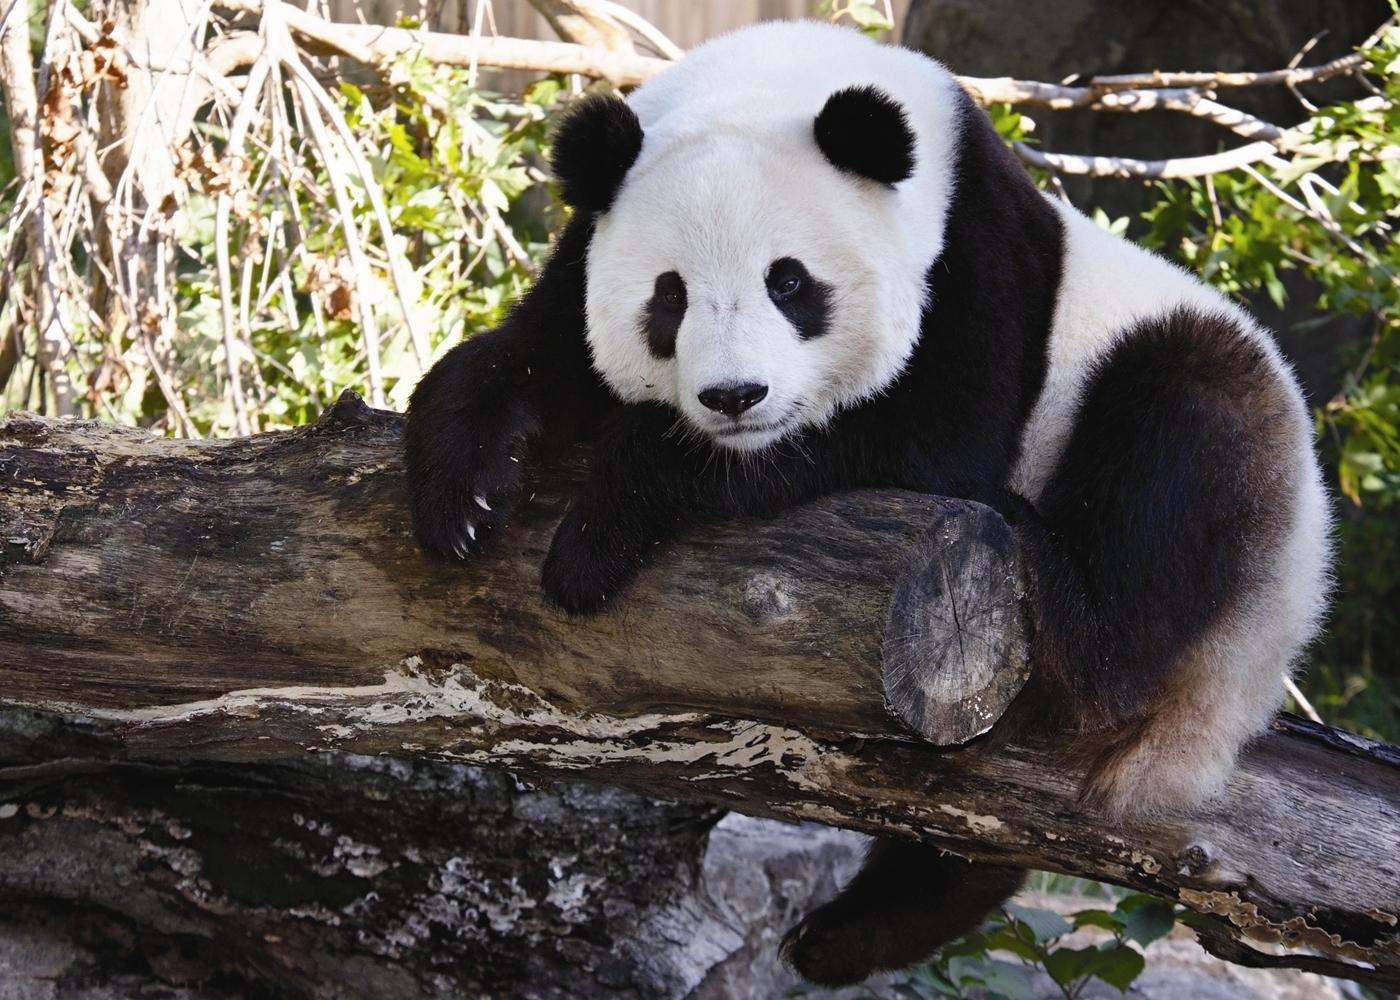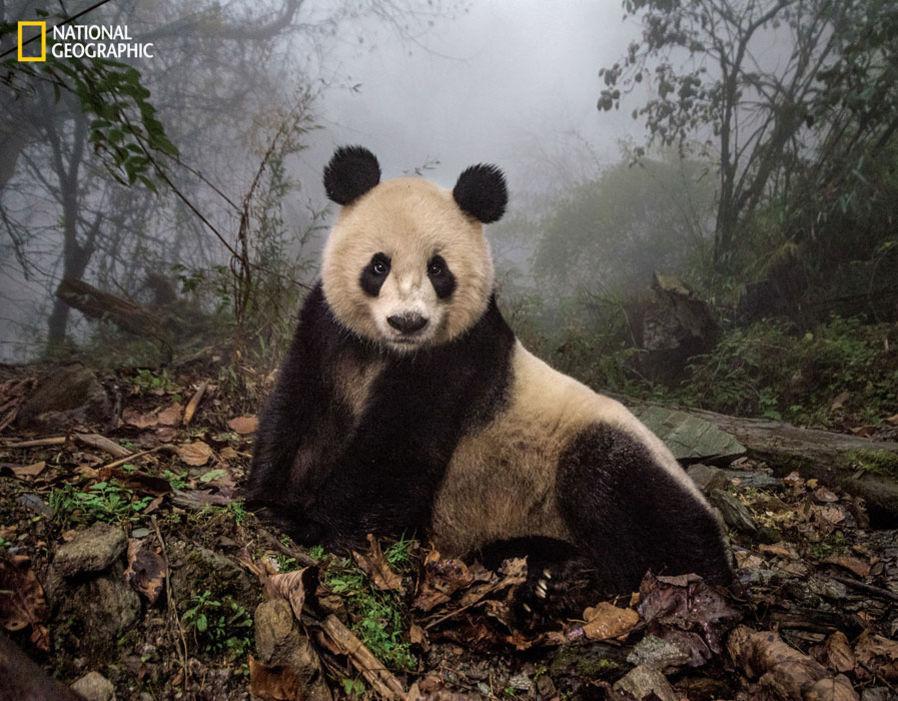The first image is the image on the left, the second image is the image on the right. Given the left and right images, does the statement "Two pandas are on top of each other in one of the images." hold true? Answer yes or no. No. The first image is the image on the left, the second image is the image on the right. Assess this claim about the two images: "In one of the images there are exactly two pandas cuddled together.". Correct or not? Answer yes or no. No. 